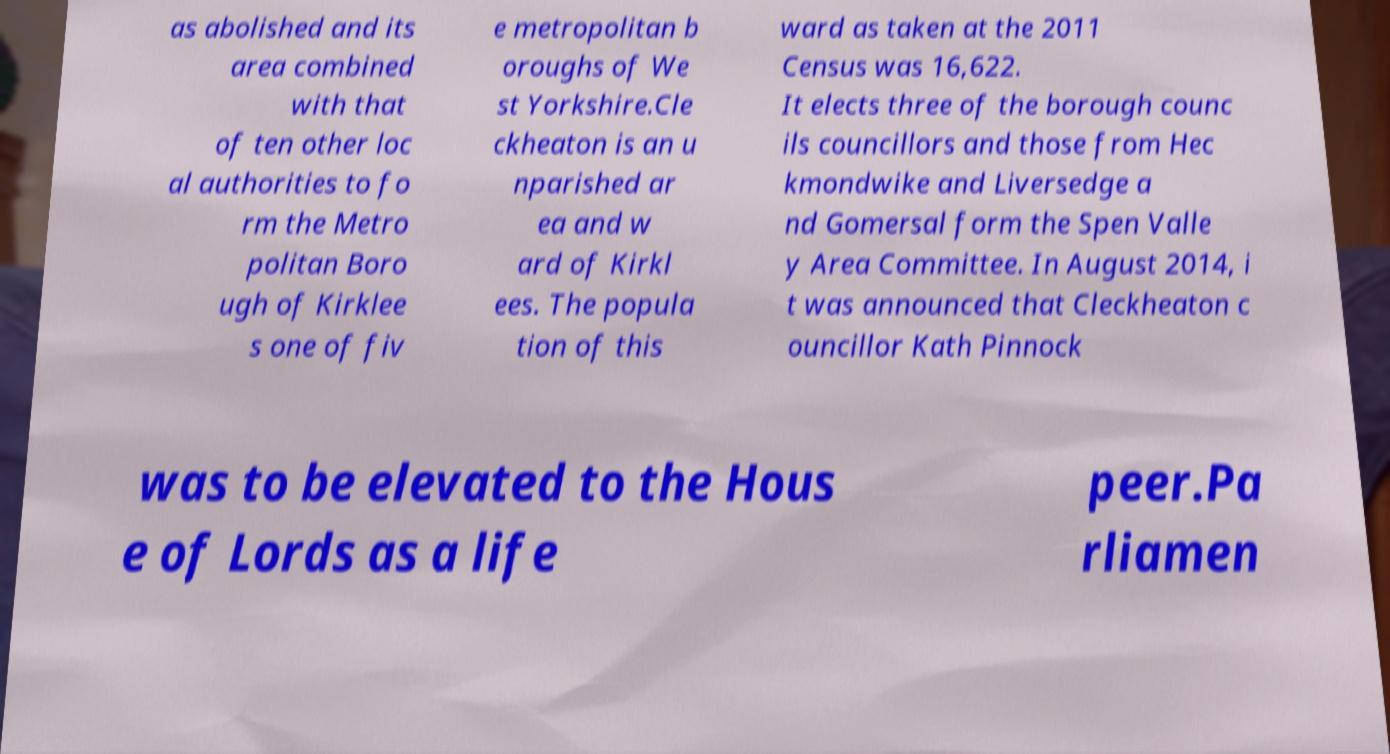Could you assist in decoding the text presented in this image and type it out clearly? as abolished and its area combined with that of ten other loc al authorities to fo rm the Metro politan Boro ugh of Kirklee s one of fiv e metropolitan b oroughs of We st Yorkshire.Cle ckheaton is an u nparished ar ea and w ard of Kirkl ees. The popula tion of this ward as taken at the 2011 Census was 16,622. It elects three of the borough counc ils councillors and those from Hec kmondwike and Liversedge a nd Gomersal form the Spen Valle y Area Committee. In August 2014, i t was announced that Cleckheaton c ouncillor Kath Pinnock was to be elevated to the Hous e of Lords as a life peer.Pa rliamen 